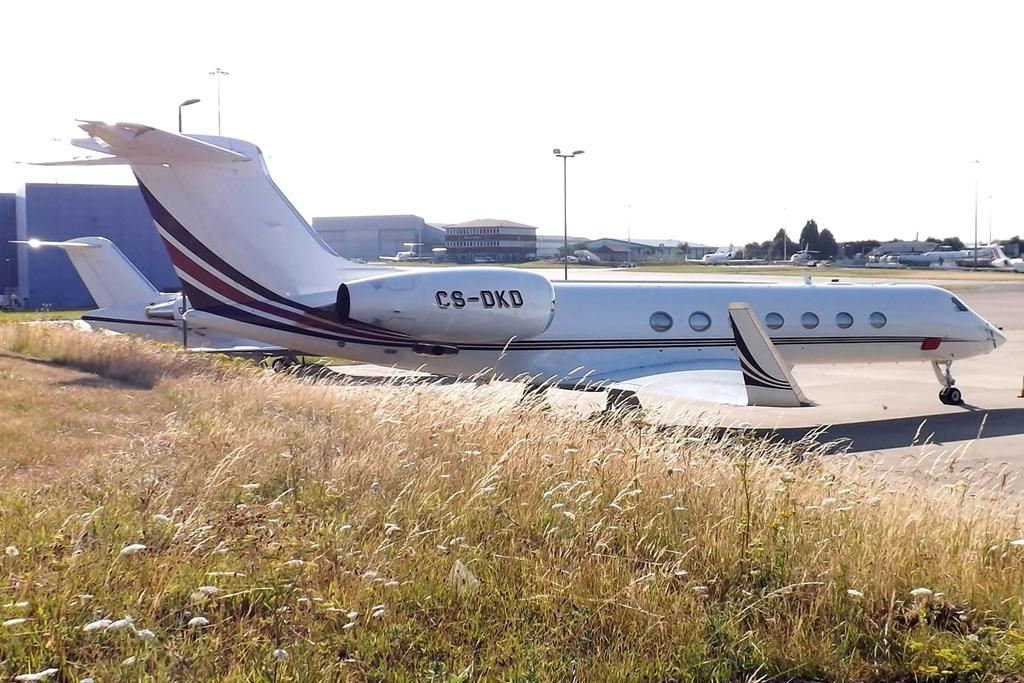<image>
Offer a succinct explanation of the picture presented. The passenger aircraft C8-DKD is parked along a grassy area on the tarmac. 